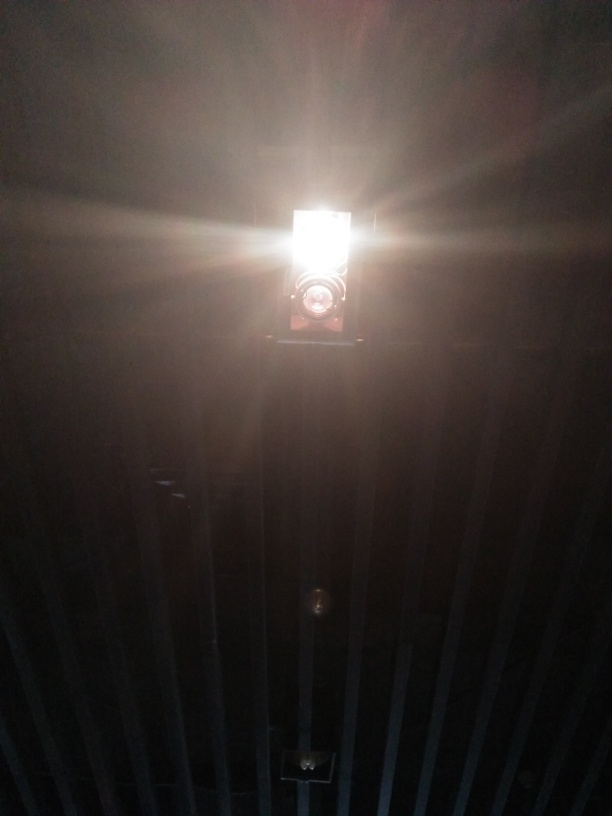What type of setting does this image depict? The photo seems to be taken in a space with structured lines, possibly an industrial setting or a location with exposed structural elements like beams, suggesting a raw, utilitarian environment. 